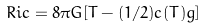<formula> <loc_0><loc_0><loc_500><loc_500>R i c = 8 \pi G [ T - ( 1 / 2 ) c ( T ) g ]</formula> 